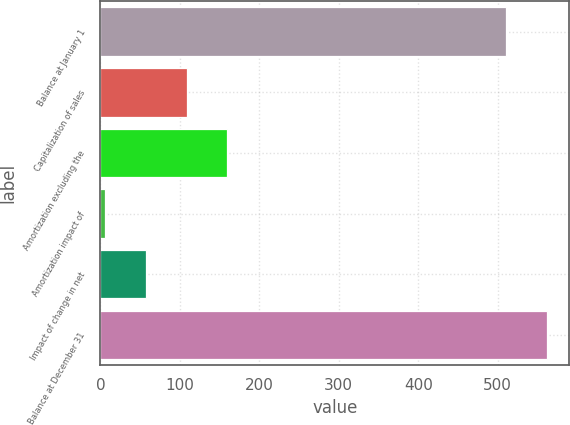Convert chart. <chart><loc_0><loc_0><loc_500><loc_500><bar_chart><fcel>Balance at January 1<fcel>Capitalization of sales<fcel>Amortization excluding the<fcel>Amortization impact of<fcel>Impact of change in net<fcel>Balance at December 31<nl><fcel>511<fcel>108.4<fcel>159.6<fcel>6<fcel>57.2<fcel>562.2<nl></chart> 